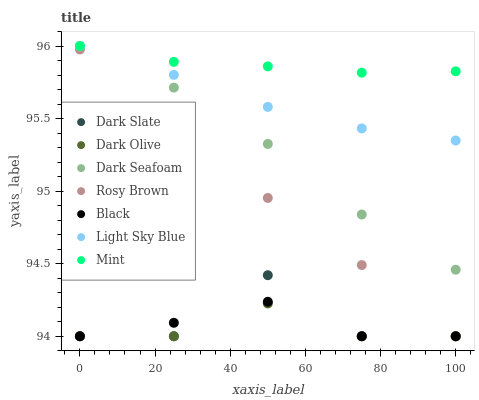Does Dark Olive have the minimum area under the curve?
Answer yes or no. Yes. Does Mint have the maximum area under the curve?
Answer yes or no. Yes. Does Dark Slate have the minimum area under the curve?
Answer yes or no. No. Does Dark Slate have the maximum area under the curve?
Answer yes or no. No. Is Mint the smoothest?
Answer yes or no. Yes. Is Dark Slate the roughest?
Answer yes or no. Yes. Is Dark Olive the smoothest?
Answer yes or no. No. Is Dark Olive the roughest?
Answer yes or no. No. Does Rosy Brown have the lowest value?
Answer yes or no. Yes. Does Dark Seafoam have the lowest value?
Answer yes or no. No. Does Mint have the highest value?
Answer yes or no. Yes. Does Dark Slate have the highest value?
Answer yes or no. No. Is Dark Olive less than Light Sky Blue?
Answer yes or no. Yes. Is Dark Seafoam greater than Dark Olive?
Answer yes or no. Yes. Does Dark Seafoam intersect Light Sky Blue?
Answer yes or no. Yes. Is Dark Seafoam less than Light Sky Blue?
Answer yes or no. No. Is Dark Seafoam greater than Light Sky Blue?
Answer yes or no. No. Does Dark Olive intersect Light Sky Blue?
Answer yes or no. No. 